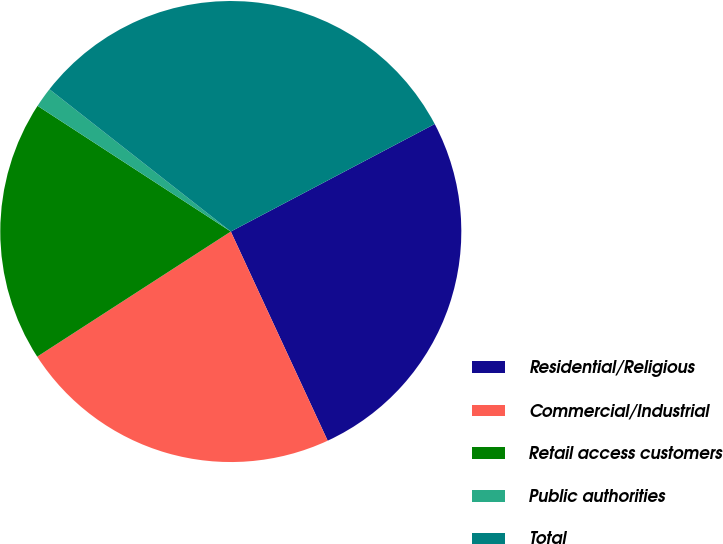<chart> <loc_0><loc_0><loc_500><loc_500><pie_chart><fcel>Residential/Religious<fcel>Commercial/Industrial<fcel>Retail access customers<fcel>Public authorities<fcel>Total<nl><fcel>25.82%<fcel>22.77%<fcel>18.31%<fcel>1.41%<fcel>31.69%<nl></chart> 